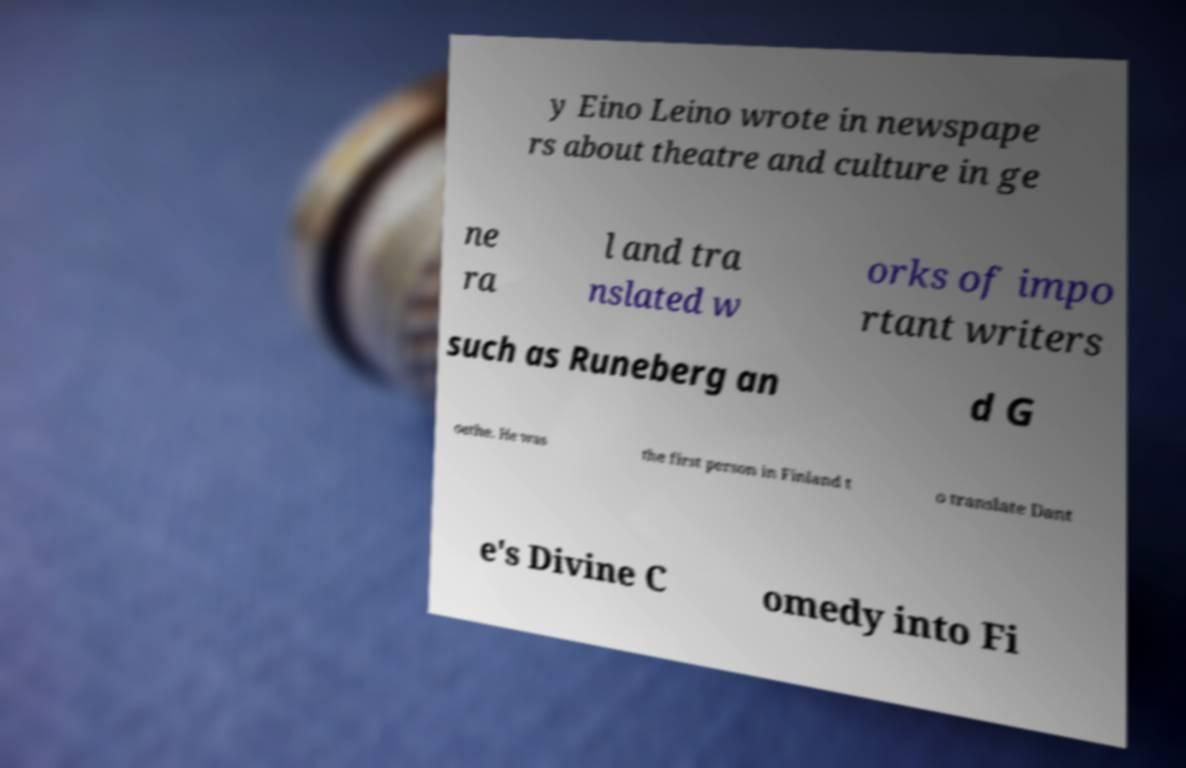Please read and relay the text visible in this image. What does it say? y Eino Leino wrote in newspape rs about theatre and culture in ge ne ra l and tra nslated w orks of impo rtant writers such as Runeberg an d G oethe. He was the first person in Finland t o translate Dant e's Divine C omedy into Fi 